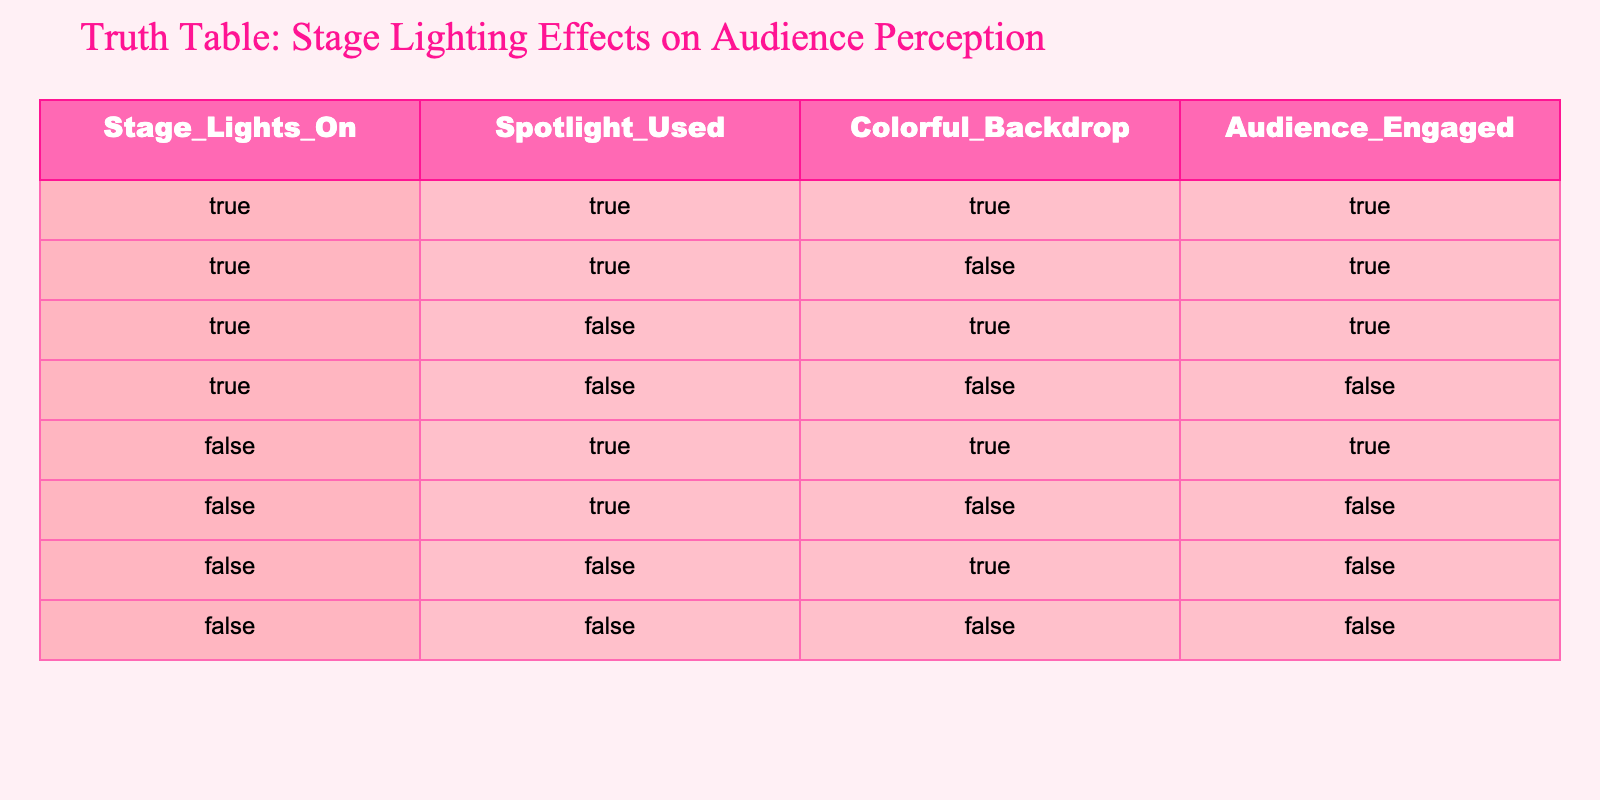What is the total number of rows where the audience is engaged? There are 5 rows in total where "Audience_Engaged" is True. Those rows are: (True, True, True), (True, True, False), (True, False, True), (False, True, True). Counting these gives a total of 4 rows.
Answer: 4 Is the audience engaged when the stage lights are off? Examining the rows where "Stage_Lights_On" is False, we see that the audience is engaged only in one row: (False, True, True). So when the stage lights are off, the audience is not universally engaged.
Answer: No How many times was the spotlight used when the audience was engaged? Looking through the rows where "Audience_Engaged" is True, we find the spotlight was used in three instances: (True, True, True), (True, True, False), and (False, True, True). Therefore, the spotlight was used 3 times when the audience was engaged.
Answer: 3 What proportion of observations involve a colorful backdrop when the stage lights are on? Out of the total scenarios where "Stage_Lights_On" is True (which is 4), colorful backdrops are present in 3 of those scenarios: (True, True, True), (True, True, False), and (True, False, True). To find the proportion: 3/4 = 0.75.
Answer: 0.75 Is there a row where both the spotlight is used and the colorful backdrop is present without engaging the audience? Checking the rows, we see that (True, True, False) uses the spotlight and has a colorful backdrop, yet the audience is engaged. However, (False, True, False) has the spotlight, no backdrop, and the audience is not engaged. There is no row meeting this condition with both features while not engaging the audience.
Answer: No What combination of lights results in audience disconnection? Identifying the rows where "Audience_Engaged" is False, we find two rows: (True, False, False) and (False, False, False). Both indicate that either using no spotlight or not using any lights leads to disconnection.
Answer: True, False 